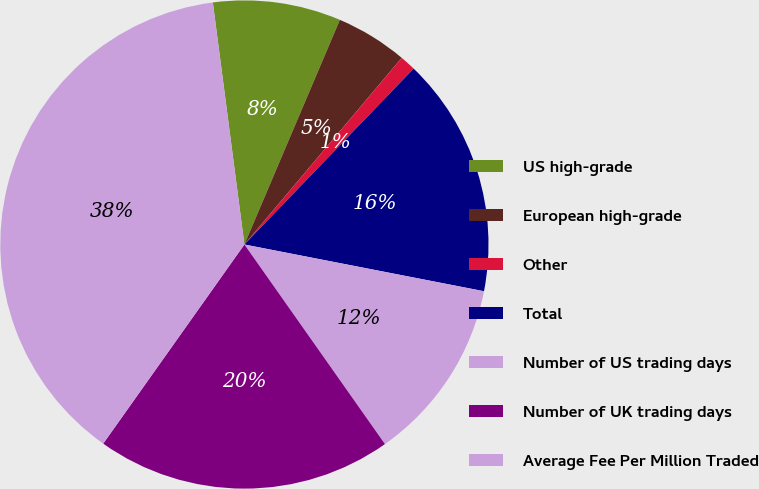<chart> <loc_0><loc_0><loc_500><loc_500><pie_chart><fcel>US high-grade<fcel>European high-grade<fcel>Other<fcel>Total<fcel>Number of US trading days<fcel>Number of UK trading days<fcel>Average Fee Per Million Traded<nl><fcel>8.46%<fcel>4.75%<fcel>1.05%<fcel>15.87%<fcel>12.17%<fcel>19.58%<fcel>38.12%<nl></chart> 